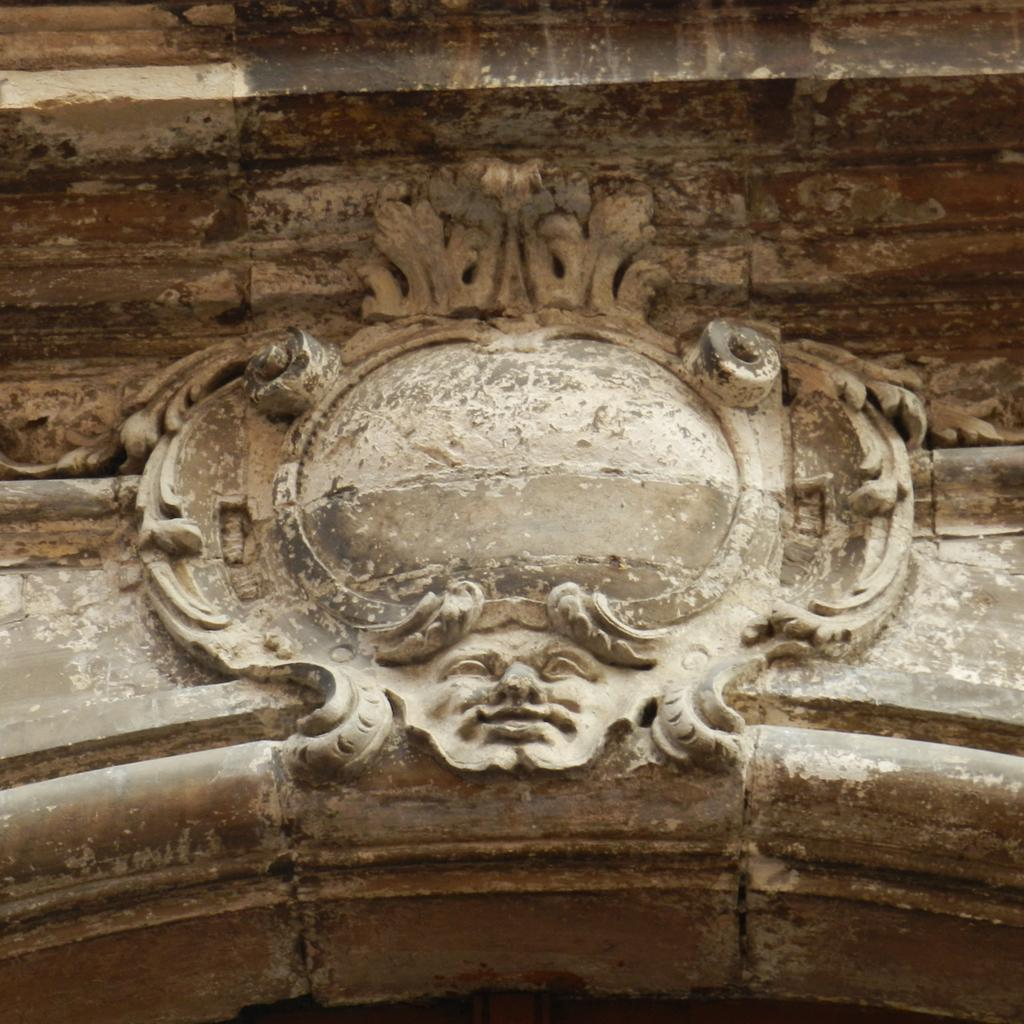What type of cave can be seen in the background of the image? There is no cave present in the image. What is the order of the cannons in the image? There are no cannons present in the image. 